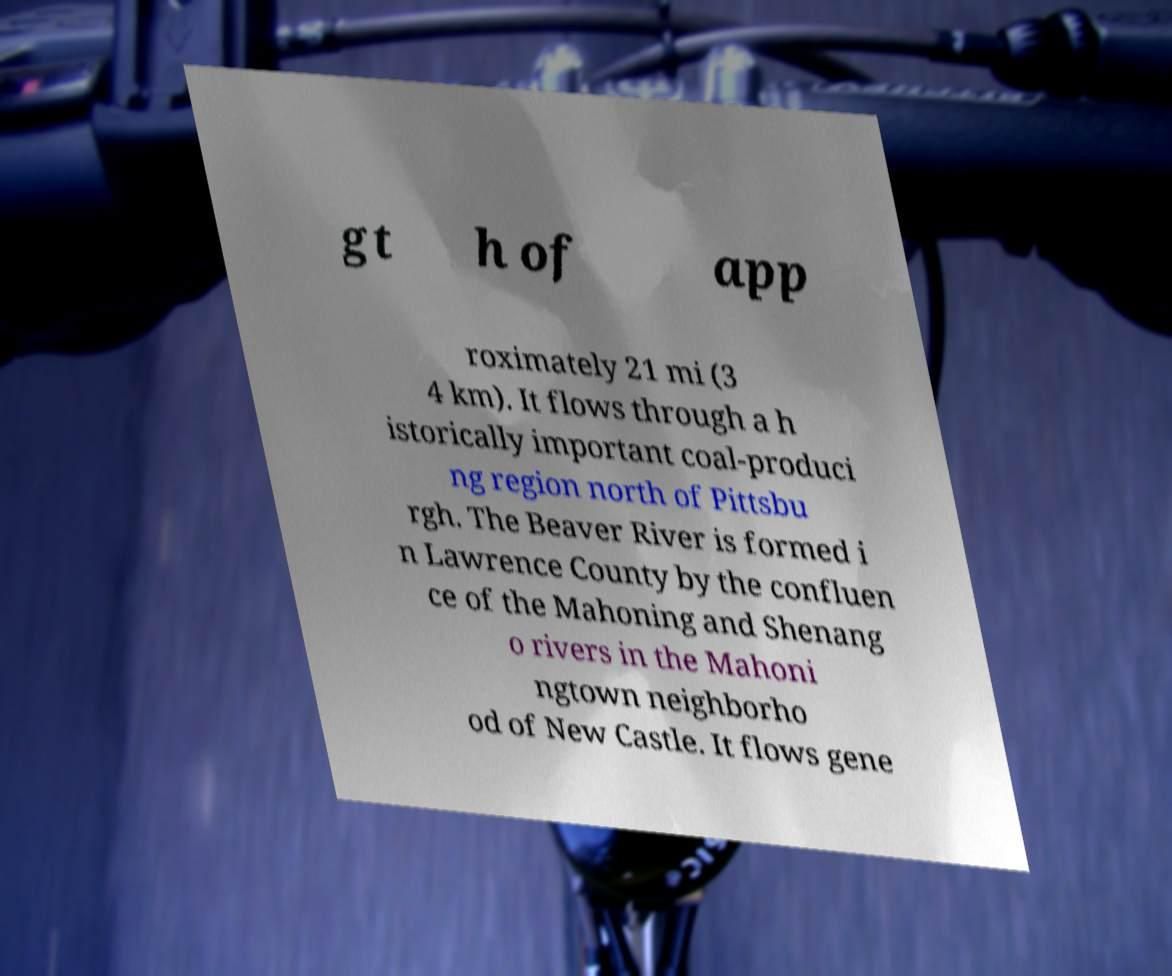Can you read and provide the text displayed in the image?This photo seems to have some interesting text. Can you extract and type it out for me? gt h of app roximately 21 mi (3 4 km). It flows through a h istorically important coal-produci ng region north of Pittsbu rgh. The Beaver River is formed i n Lawrence County by the confluen ce of the Mahoning and Shenang o rivers in the Mahoni ngtown neighborho od of New Castle. It flows gene 